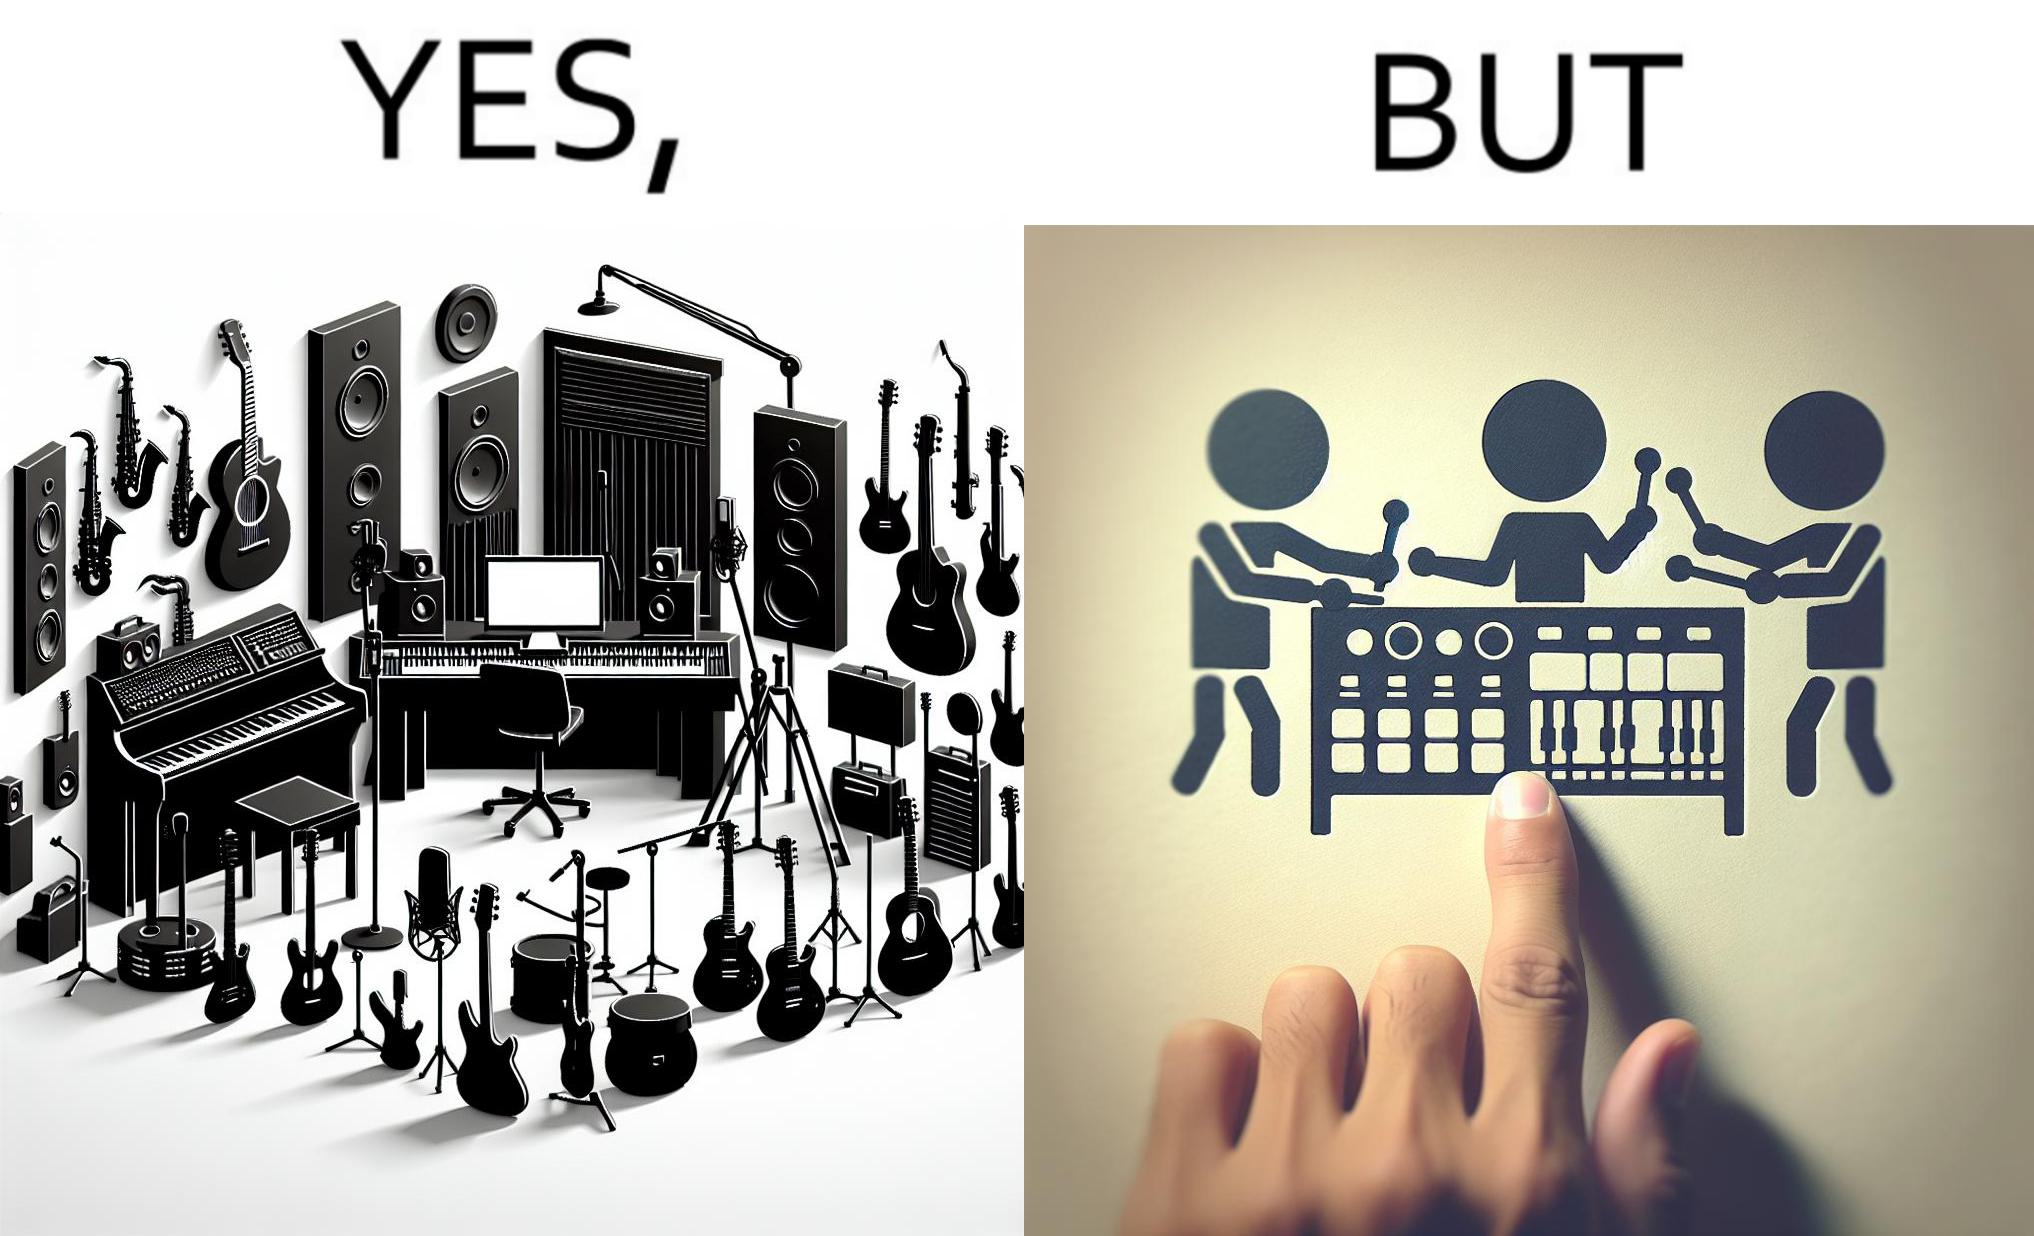What is the satirical meaning behind this image? The image overall is funny because even though people have great music studios and instruments to create and record music, they use electronic replacements of the musical instruments to achieve the task. 